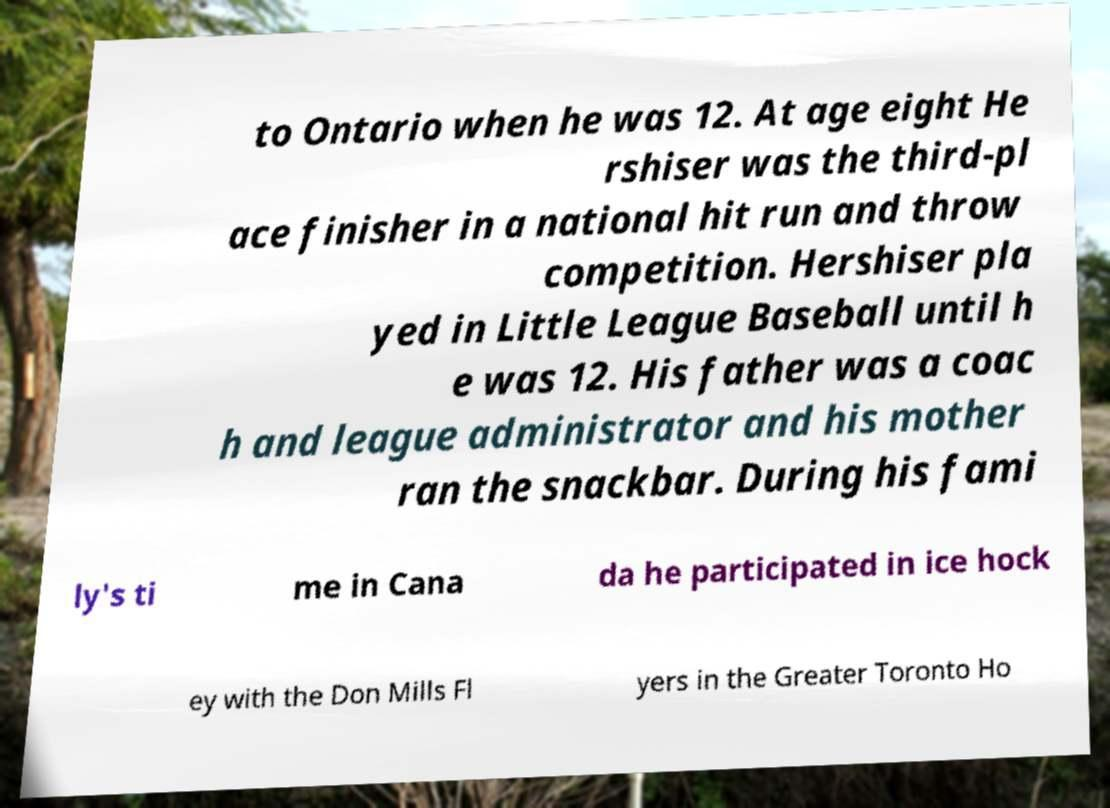Please identify and transcribe the text found in this image. to Ontario when he was 12. At age eight He rshiser was the third-pl ace finisher in a national hit run and throw competition. Hershiser pla yed in Little League Baseball until h e was 12. His father was a coac h and league administrator and his mother ran the snackbar. During his fami ly's ti me in Cana da he participated in ice hock ey with the Don Mills Fl yers in the Greater Toronto Ho 